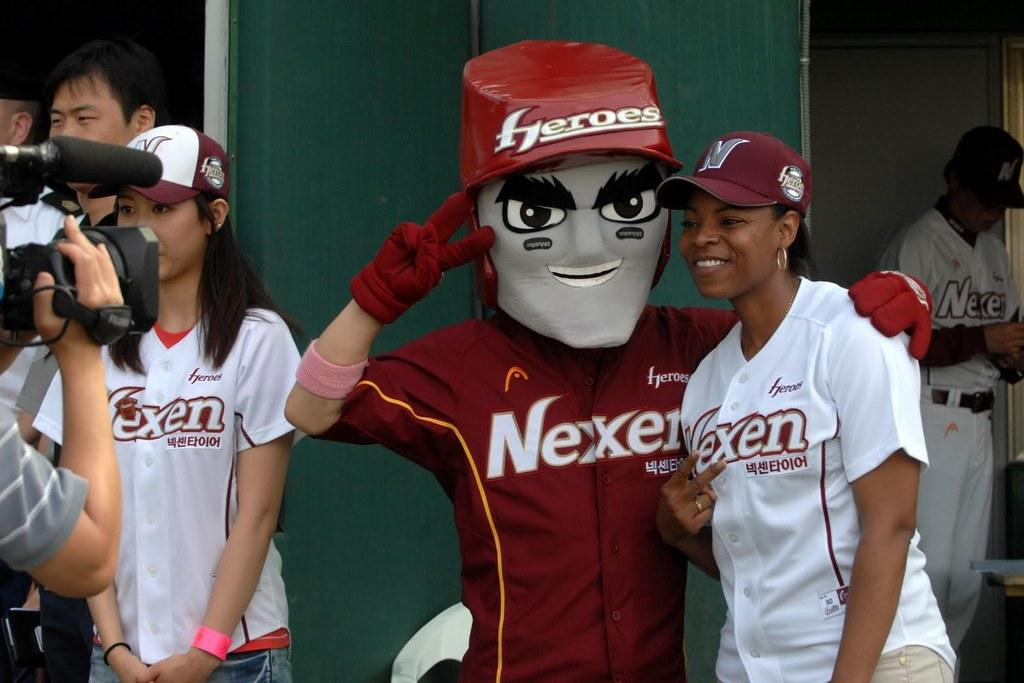<image>
Present a compact description of the photo's key features. Two women and the mascot for the Nexen team pose for the camera. 